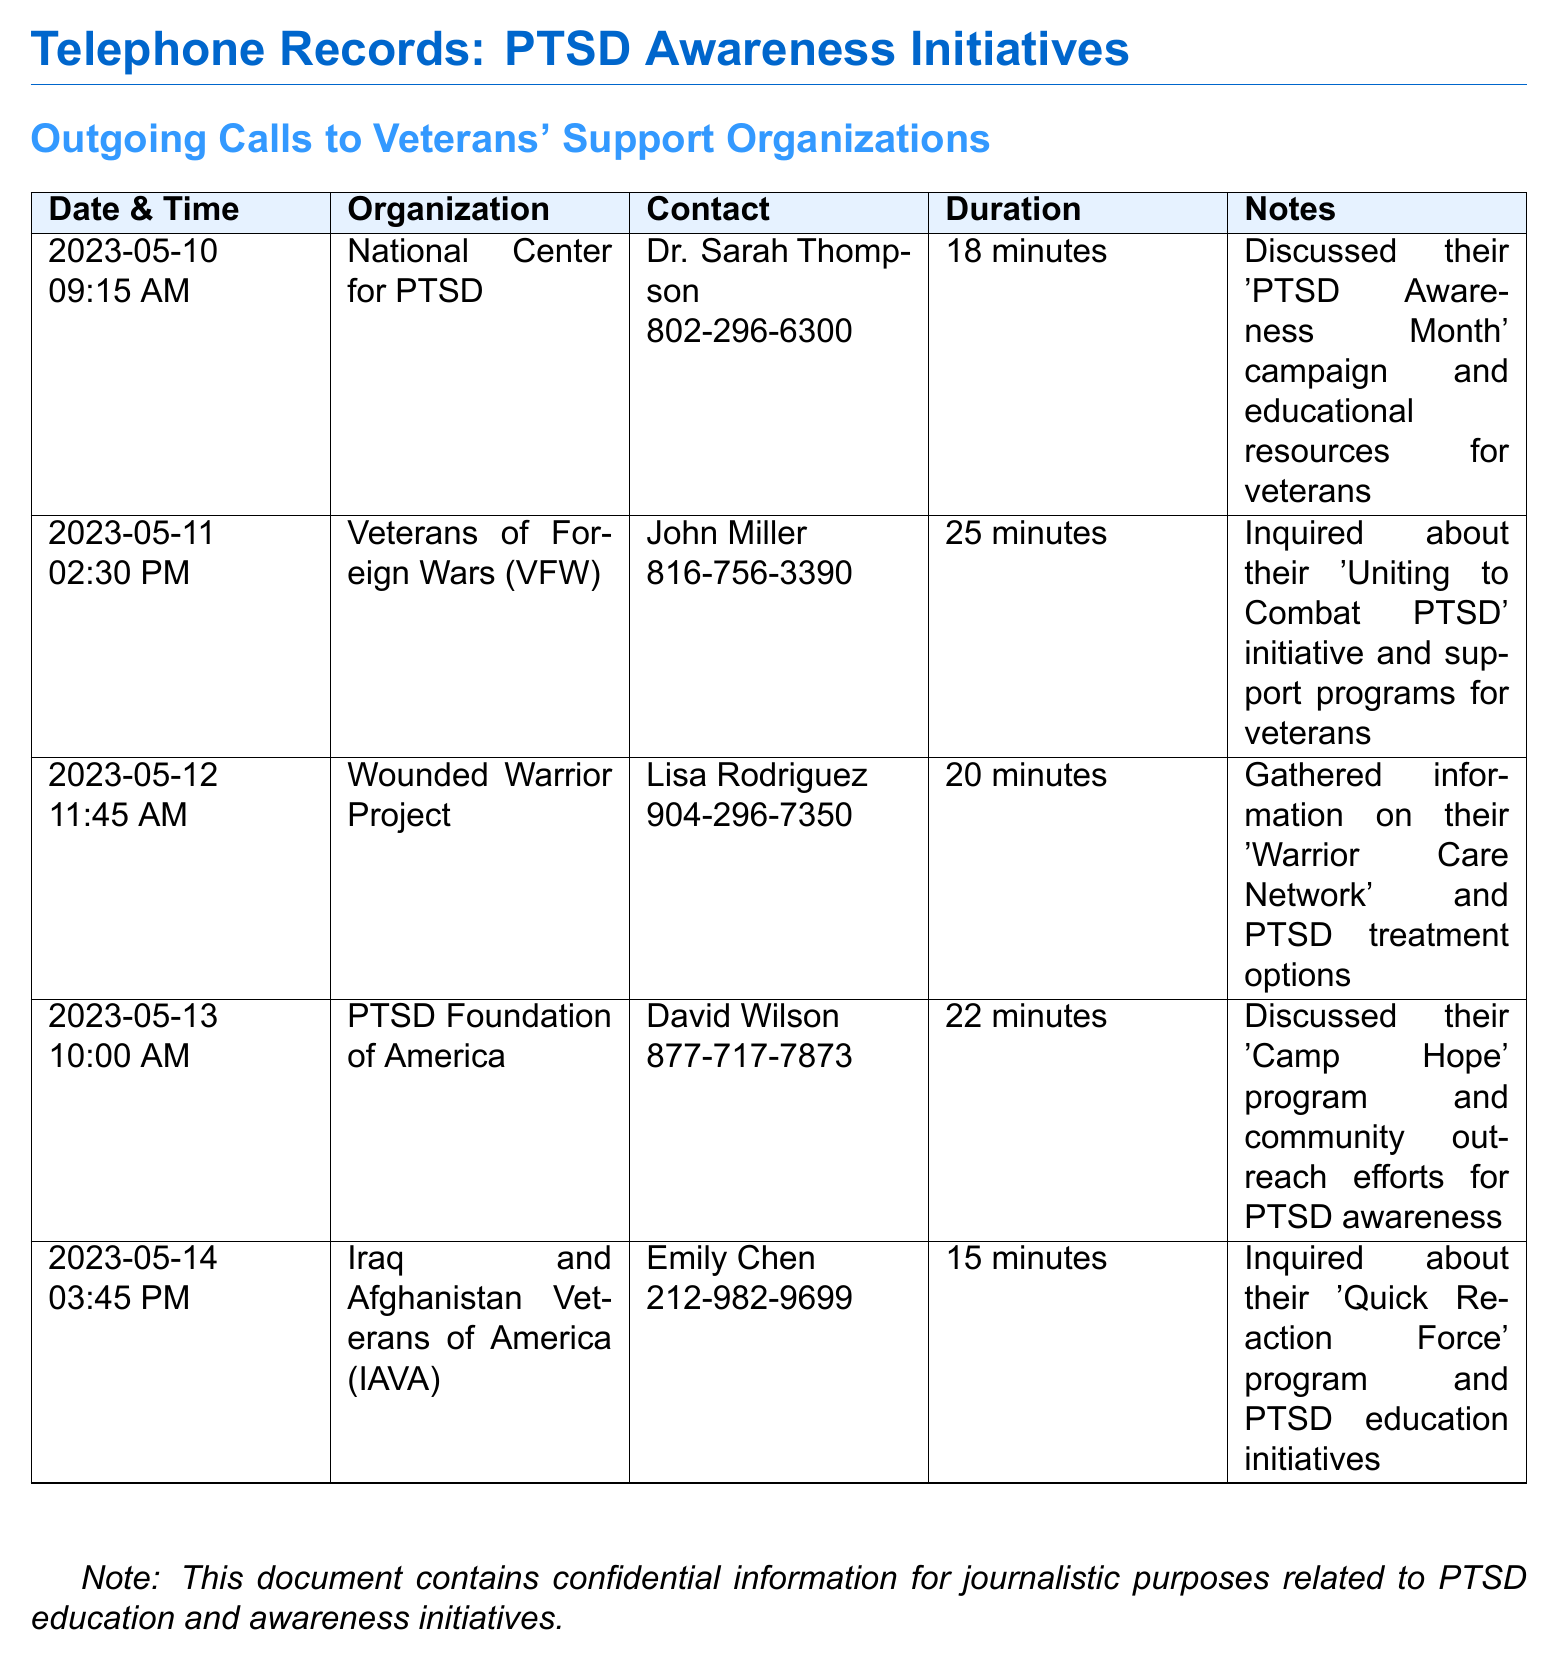What was the date of the first call? The first call took place on 2023-05-10 according to the document.
Answer: 2023-05-10 Who was the contact person at the National Center for PTSD? The contact person listed is Dr. Sarah Thompson.
Answer: Dr. Sarah Thompson How long did the call with the PTSD Foundation of America last? The duration of the call with the PTSD Foundation of America was noted as 22 minutes.
Answer: 22 minutes What initiative was discussed with Veterans of Foreign Wars? The initiative discussed was the 'Uniting to Combat PTSD'.
Answer: 'Uniting to Combat PTSD' How many organizations were contacted regarding PTSD initiatives? There were a total of five organizations contacted in the record.
Answer: Five Which program was mentioned in the call with Iraq and Afghanistan Veterans of America? The program mentioned was the 'Quick Reaction Force'.
Answer: 'Quick Reaction Force' What was the main topic of the conversation with Lisa Rodriguez from Wounded Warrior Project? The main topic was the 'Warrior Care Network' and PTSD treatment options.
Answer: 'Warrior Care Network' What time was the call made to the National Center for PTSD? The call to the National Center for PTSD was made at 09:15 AM.
Answer: 09:15 AM What is the duration of the call with Emily Chen from IAVA? The call duration with Emily Chen was recorded as 15 minutes.
Answer: 15 minutes 